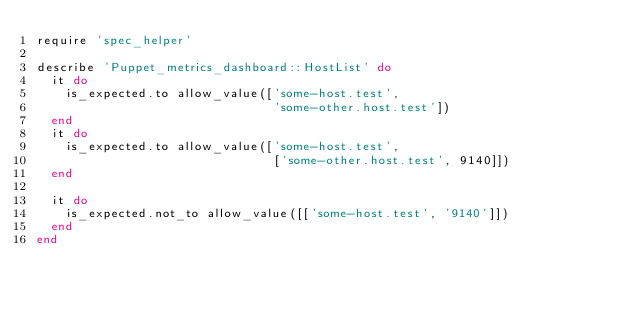<code> <loc_0><loc_0><loc_500><loc_500><_Ruby_>require 'spec_helper'

describe 'Puppet_metrics_dashboard::HostList' do
  it do
    is_expected.to allow_value(['some-host.test',
                                'some-other.host.test'])
  end
  it do
    is_expected.to allow_value(['some-host.test',
                                ['some-other.host.test', 9140]])
  end

  it do
    is_expected.not_to allow_value([['some-host.test', '9140']])
  end
end
</code> 